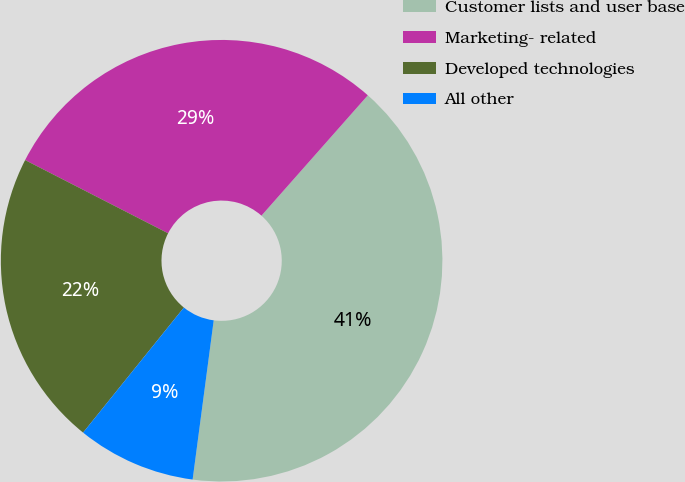Convert chart to OTSL. <chart><loc_0><loc_0><loc_500><loc_500><pie_chart><fcel>Customer lists and user base<fcel>Marketing- related<fcel>Developed technologies<fcel>All other<nl><fcel>40.58%<fcel>28.99%<fcel>21.74%<fcel>8.7%<nl></chart> 